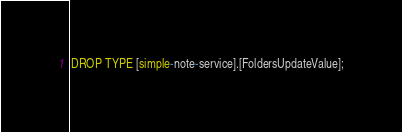<code> <loc_0><loc_0><loc_500><loc_500><_SQL_>DROP TYPE [simple-note-service].[FoldersUpdateValue];</code> 